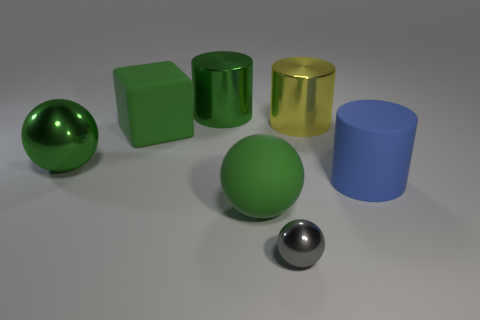How do the shapes in the image relate to each other? The image presents a thoughtful arrangement of geometric shapes: the spheres, cylinders, and cube offer a study in contrast and balance. The roundness of the spheres juxtaposes the straight edges of the cube and the cylinders, demonstrating how diverse shapes can coexist harmoniously in a single composition. 